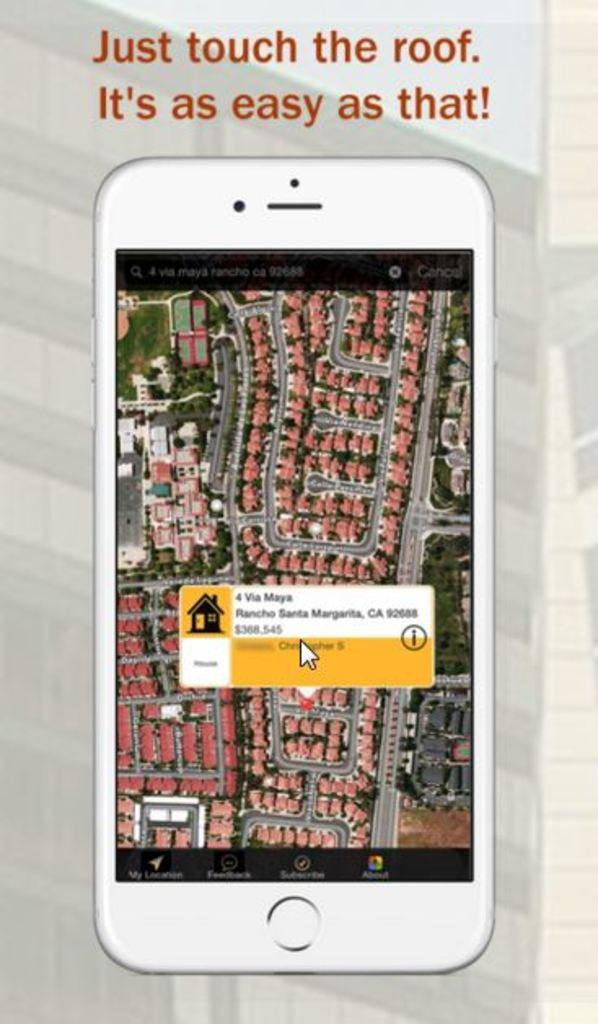<image>
Write a terse but informative summary of the picture. 4 Via Maya in Rancho Santa Margarita, California can be purchased for $368,545. 